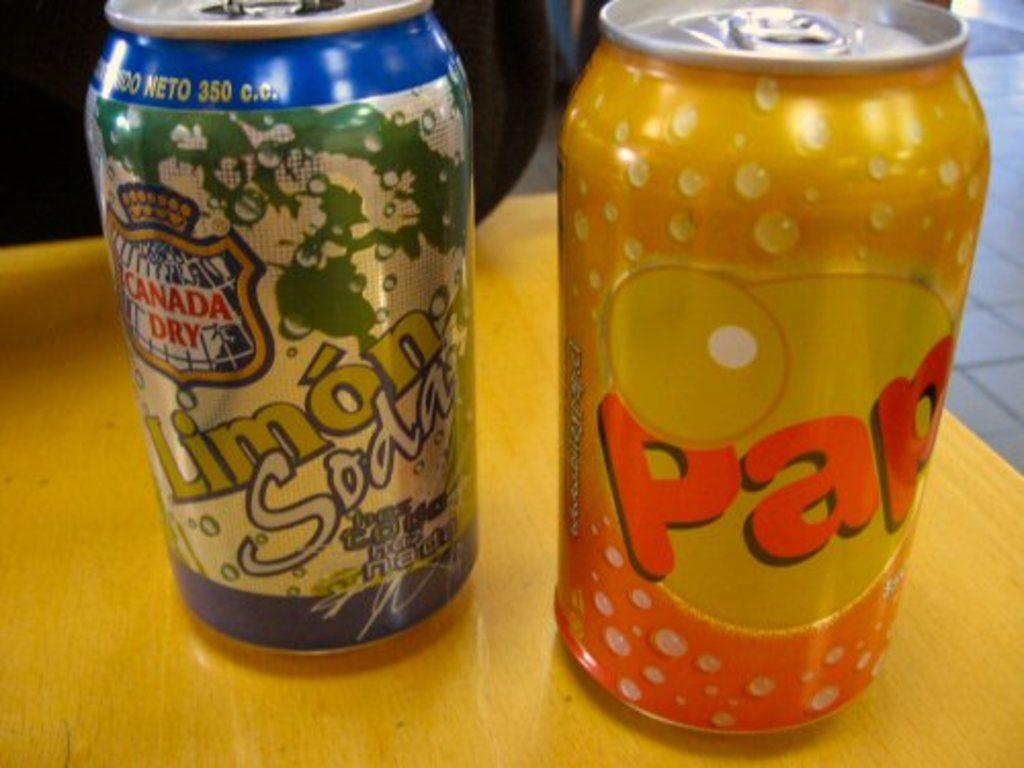What brand of ginger ale is in the table?
Give a very brief answer. Canada dry. What is the 3 digit number at the top of the green can?
Keep it short and to the point. 350. 